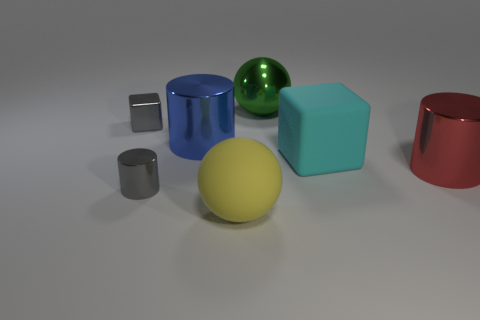What number of other objects are the same color as the tiny cube?
Your response must be concise. 1. There is a small cylinder that is the same color as the small block; what is it made of?
Your answer should be very brief. Metal. What number of green metal objects are there?
Provide a succinct answer. 1. What is the color of the tiny block that is made of the same material as the green object?
Your response must be concise. Gray. How many big things are either red shiny balls or cylinders?
Your answer should be compact. 2. There is a blue metal object; how many tiny gray metallic things are in front of it?
Ensure brevity in your answer.  1. What is the color of the small shiny object that is the same shape as the cyan matte object?
Your answer should be compact. Gray. How many metallic objects are large red cylinders or green spheres?
Your answer should be very brief. 2. There is a sphere in front of the gray thing that is in front of the gray block; is there a big cyan thing that is in front of it?
Give a very brief answer. No. The small metal cylinder is what color?
Offer a very short reply. Gray. 